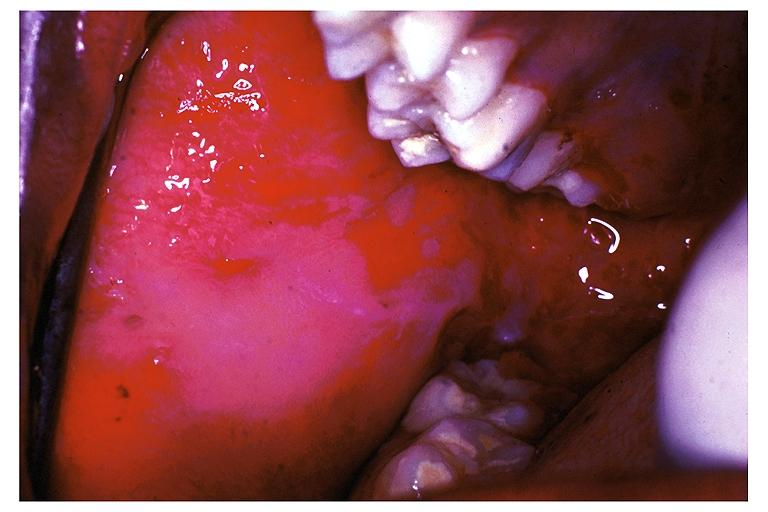what is present?
Answer the question using a single word or phrase. Oral 